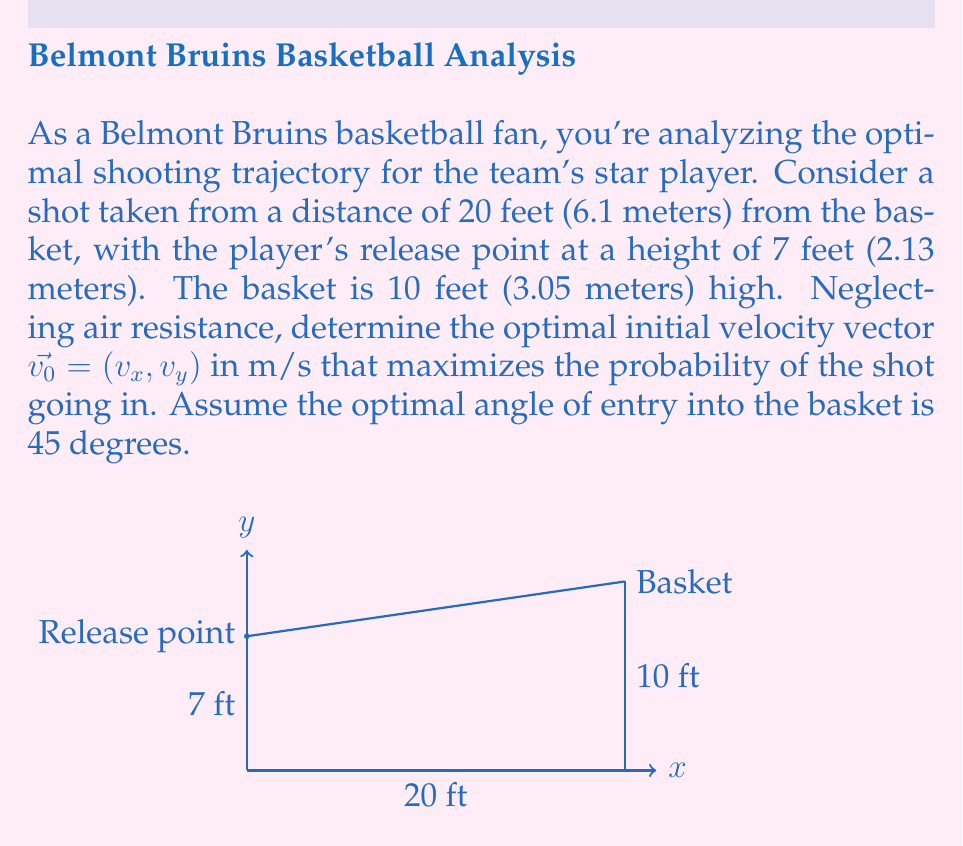Teach me how to tackle this problem. To solve this problem, we'll use the equations of projectile motion and differential equations. Let's approach this step-by-step:

1) The trajectory of the basketball can be described by the following differential equations:

   $$\frac{d^2x}{dt^2} = 0$$
   $$\frac{d^2y}{dt^2} = -g$$

   where $g$ is the acceleration due to gravity (9.8 m/s²).

2) Integrating these equations with initial conditions $x(0) = 0$, $y(0) = 2.13$, $\frac{dx}{dt}(0) = v_x$, and $\frac{dy}{dt}(0) = v_y$, we get:

   $$x(t) = v_xt$$
   $$y(t) = 2.13 + v_yt - \frac{1}{2}gt^2$$

3) We know that the ball must reach the basket at $x = 6.1$ and $y = 3.05$. Let's call the time it takes to reach the basket $T$. Then:

   $$6.1 = v_xT$$
   $$3.05 = 2.13 + v_yT - \frac{1}{2}gT^2$$

4) For the optimal 45° entry angle, the velocity at the basket should satisfy:

   $$\frac{dy}{dx} = \tan(45°) = 1 = \frac{v_y - gT}{v_x}$$

5) From steps 3 and 4, we have three equations and three unknowns ($v_x$, $v_y$, and $T$). Solving these simultaneously:

   $$v_x = \frac{6.1}{T}$$
   $$v_y = v_x + gT = \frac{6.1}{T} + 9.8T$$
   $$3.05 = 2.13 + (\frac{6.1}{T} + 9.8T)T - \frac{1}{2}9.8T^2$$

6) Simplifying the last equation:

   $$0.92 = 6.1 + 4.9T^2$$
   $$T^2 = \frac{0.92 - 6.1}{4.9} = -1.0571$$
   $$T = \sqrt{1.0571} = 1.0282 \text{ seconds}$$

7) Now we can calculate $v_x$ and $v_y$:

   $$v_x = \frac{6.1}{1.0282} = 5.93 \text{ m/s}$$
   $$v_y = 5.93 + 9.8(1.0282) = 16.01 \text{ m/s}$$

8) The initial velocity vector is therefore:

   $$\vec{v_0} = (5.93, 16.01) \text{ m/s}$$

9) The magnitude of this vector is:

   $$|\vec{v_0}| = \sqrt{5.93^2 + 16.01^2} = 17.09 \text{ m/s}$$

10) The angle of release can be calculated as:

    $$\theta = \tan^{-1}(\frac{v_y}{v_x}) = \tan^{-1}(\frac{16.01}{5.93}) = 69.7°$$
Answer: $\vec{v_0} = (5.93, 16.01)$ m/s, $|\vec{v_0}| = 17.09$ m/s, $\theta = 69.7°$ 